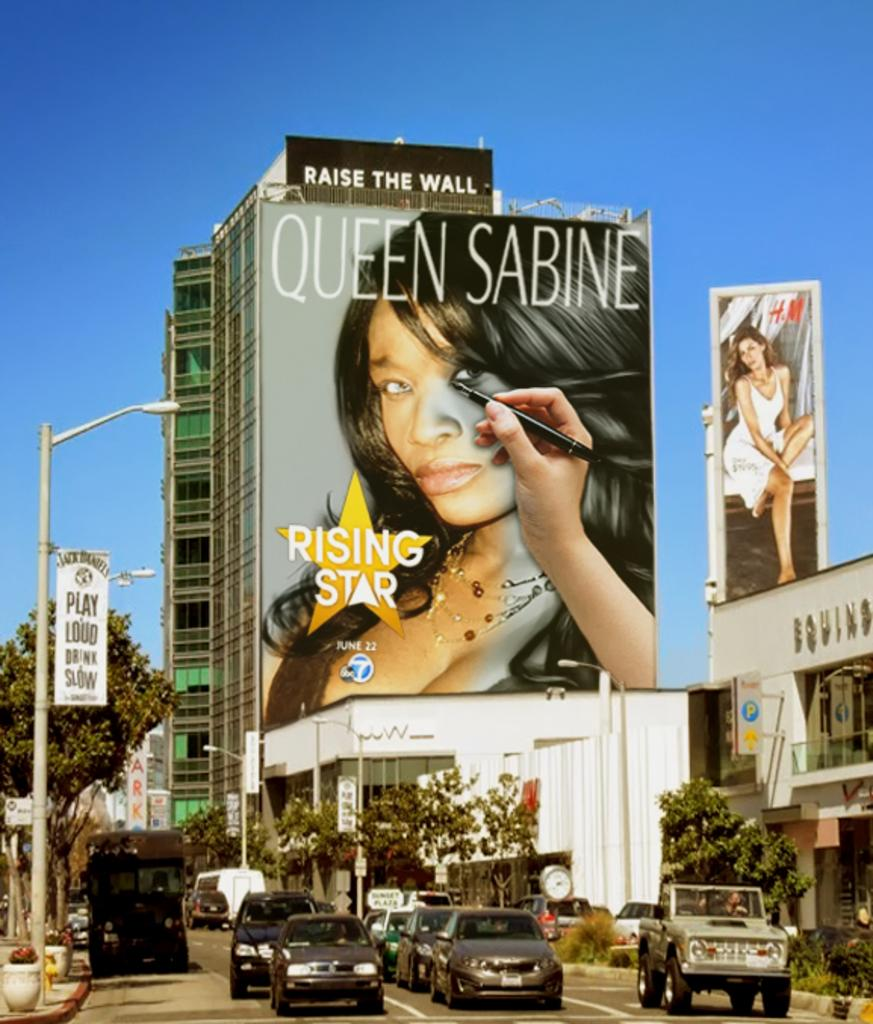Provide a one-sentence caption for the provided image. Big banner with Queen Sabine a rising star outside. 